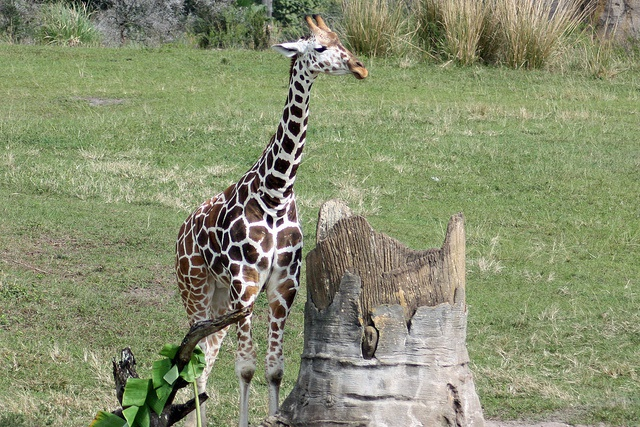Describe the objects in this image and their specific colors. I can see a giraffe in gray, black, darkgray, and lightgray tones in this image. 